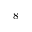<formula> <loc_0><loc_0><loc_500><loc_500>^ { 8 }</formula> 